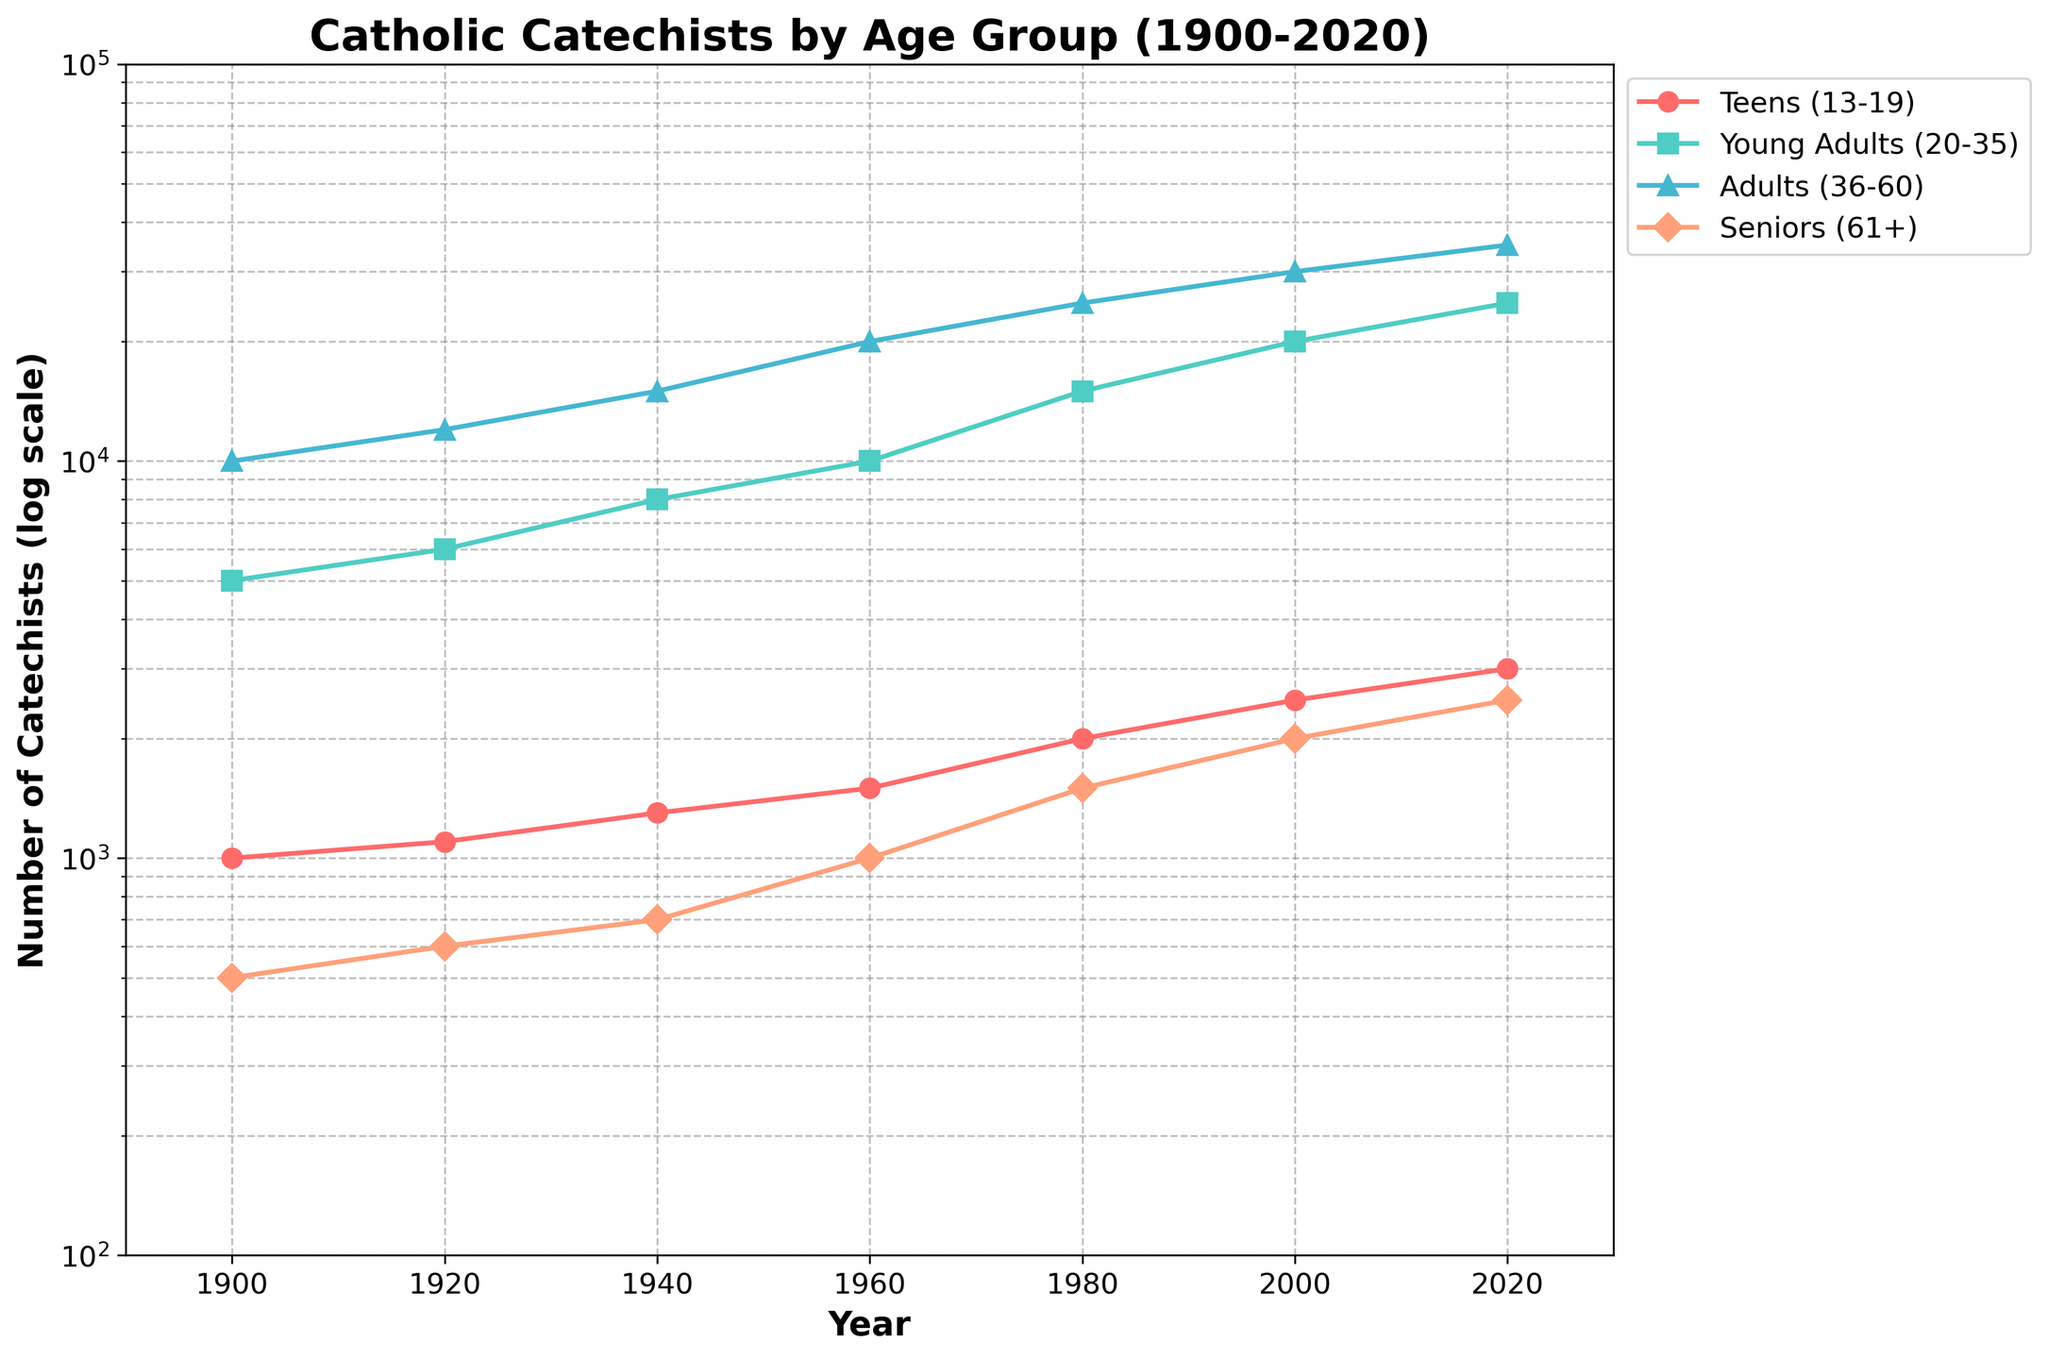What is the title of the figure? The title is usually displayed at the top of the figure. In this case, it shows the main topic of the data being visualized.
Answer: Catholic Catechists by Age Group (1900-2020) How many age groups are represented in the figure? By looking at the legend or the different colored lines and markers, we can count the number of age groups.
Answer: Four Which age group had the highest number of catechists in 2020? By locating the year 2020 on the x-axis and observing which line is highest on the y-axis for that year, we can identify the age group with the most catechists.
Answer: Adults (36-60) How did the number of teen catechists change from 1900 to 1920? Look at the value for teens (13-19) in 1900 and then again in 1920. The difference will give the change.
Answer: Increased by 100 What was the approximate number of catechists in the seniors (61+) age group in 1960? Find the year 1960 on the x-axis and look at the corresponding value on the y-axis for the seniors (61+) line.
Answer: About 1,000 How did the number of young adult catechists (20-35) change from 1980 to 2000? Compare the value for young adults in 1980 and 2000. Calculate the difference to determine the change.
Answer: Increased by 5,000 In which year did the number of adult catechists (36-60) reach 20,000? Trace the adult catechists (36-60) line and find where it hits 20,000 on the y-axis, then read the corresponding year on the x-axis.
Answer: 1960 Which age group has shown the most consistent growth over the years? By observing the trend and slope of each line over the years, identify which line appears the smoothest and least variable.
Answer: Adults (36-60) Based on the plot, what can we infer about the trend of catechists in the seniors (61+) age group? Follow the seniors (61+) line from 1900 to 2020 to observe the general direction and nature of the trend.
Answer: Consistent, moderate growth Comparing 1940 to 2000, which age group experienced the least growth in terms of catechists? Look at the values for each age group in 1940 and compare them to 2000. The age group with the smallest difference has the least growth.
Answer: Seniors (61+) 